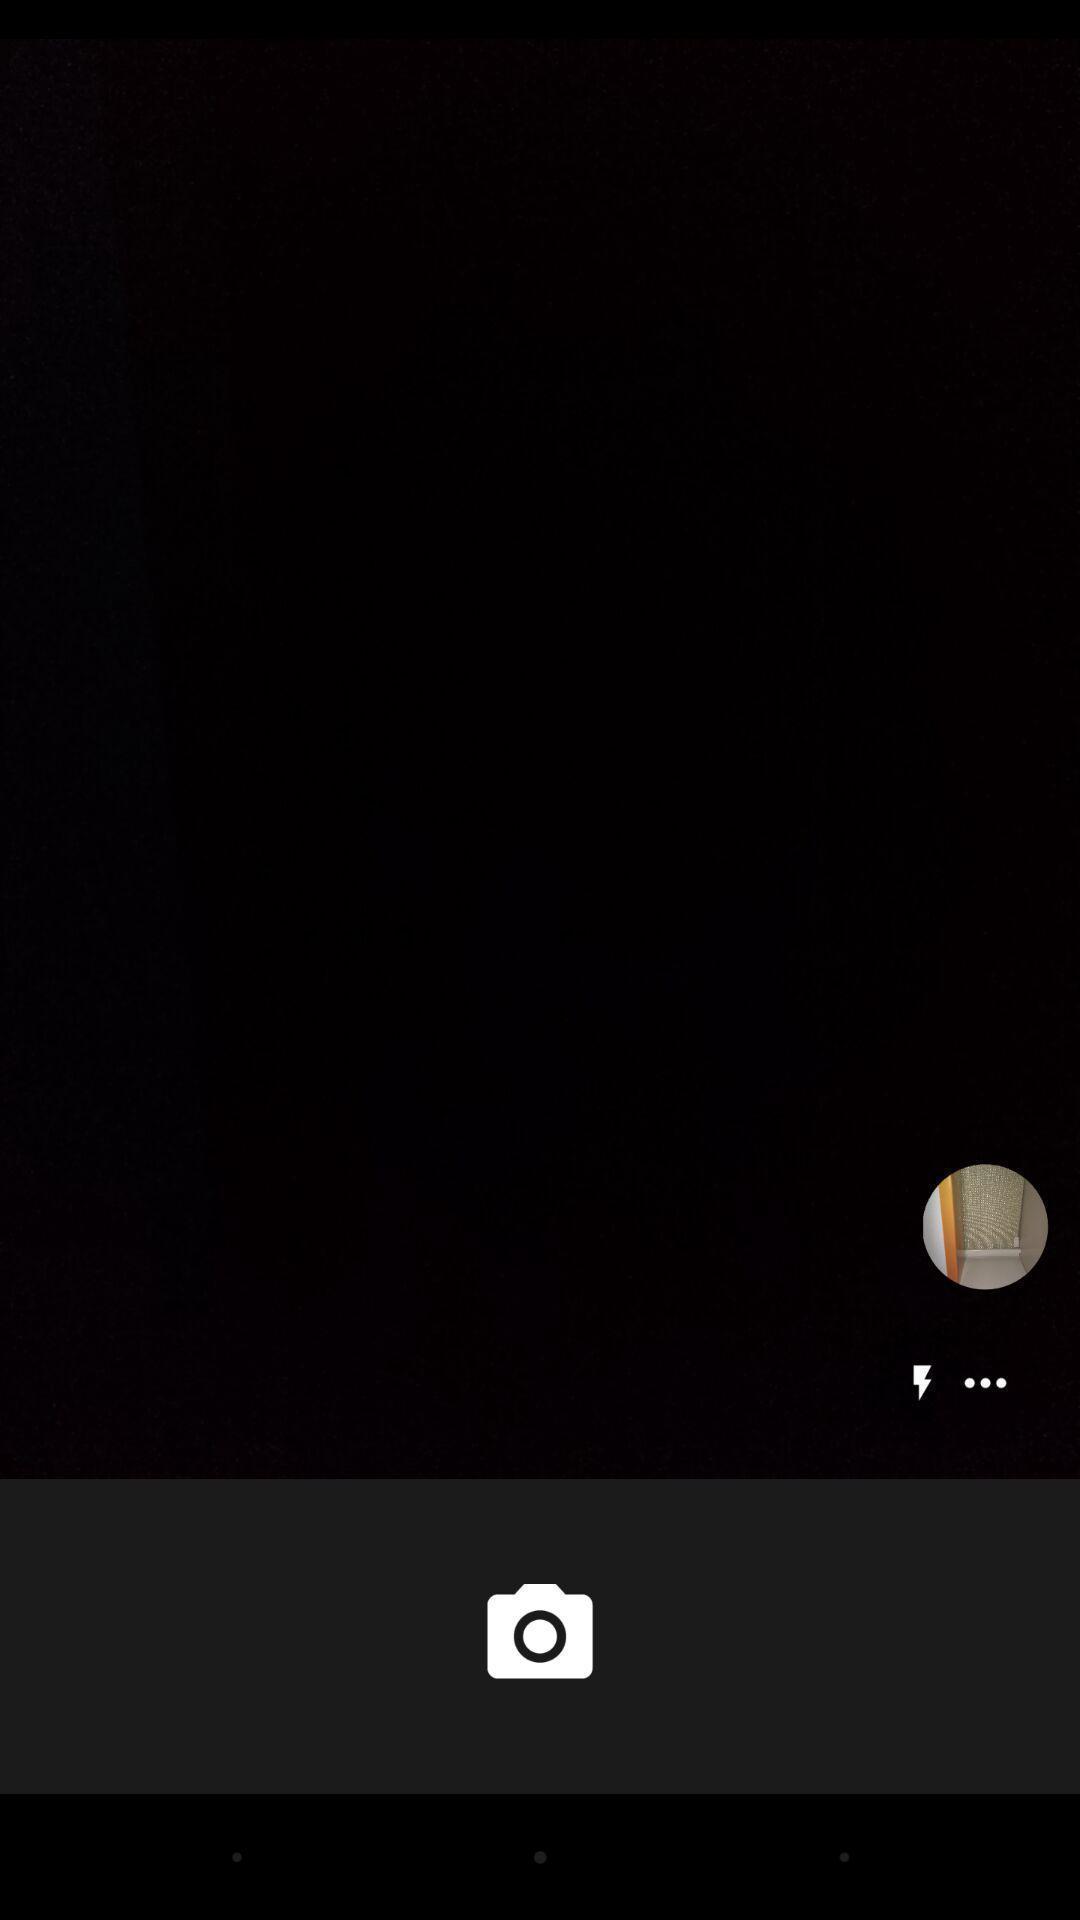Give me a summary of this screen capture. Screen displaying a blank page with camera icon. 